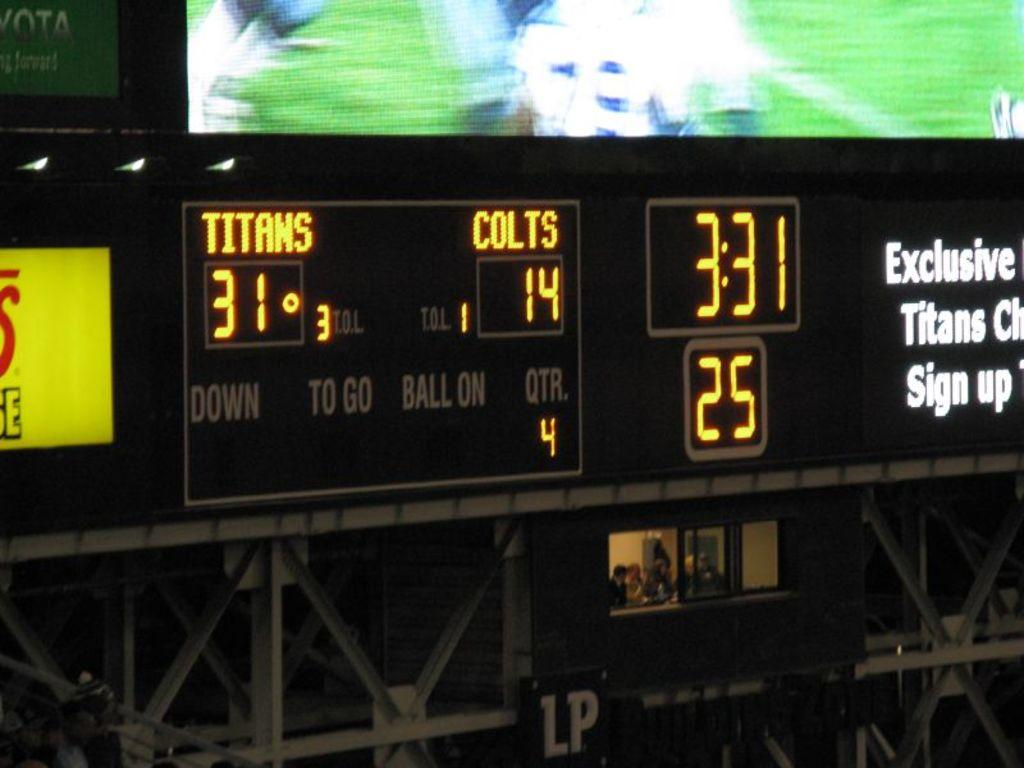<image>
Share a concise interpretation of the image provided. Scoreboard showing the score between the Titans and Colts. 